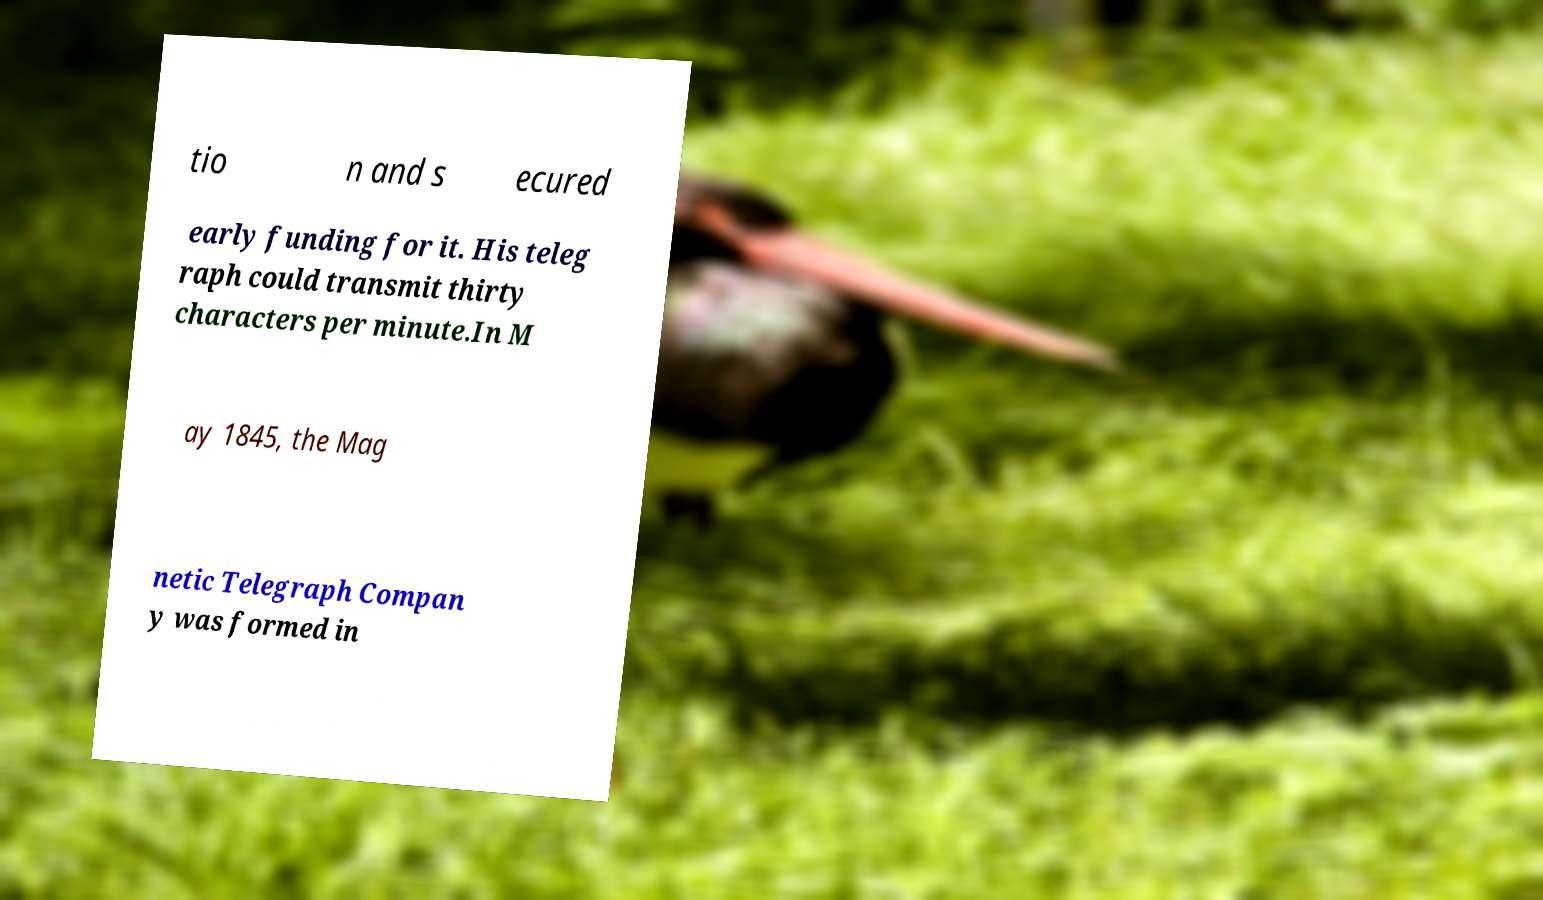Please identify and transcribe the text found in this image. tio n and s ecured early funding for it. His teleg raph could transmit thirty characters per minute.In M ay 1845, the Mag netic Telegraph Compan y was formed in 